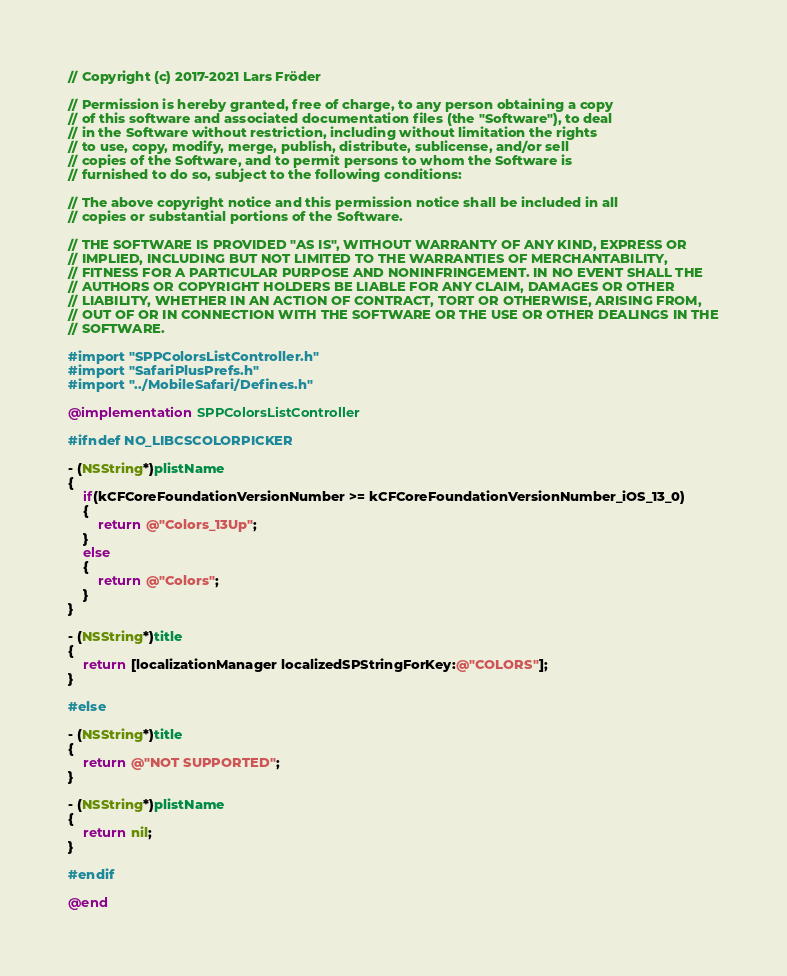Convert code to text. <code><loc_0><loc_0><loc_500><loc_500><_ObjectiveC_>// Copyright (c) 2017-2021 Lars Fröder

// Permission is hereby granted, free of charge, to any person obtaining a copy
// of this software and associated documentation files (the "Software"), to deal
// in the Software without restriction, including without limitation the rights
// to use, copy, modify, merge, publish, distribute, sublicense, and/or sell
// copies of the Software, and to permit persons to whom the Software is
// furnished to do so, subject to the following conditions:

// The above copyright notice and this permission notice shall be included in all
// copies or substantial portions of the Software.

// THE SOFTWARE IS PROVIDED "AS IS", WITHOUT WARRANTY OF ANY KIND, EXPRESS OR
// IMPLIED, INCLUDING BUT NOT LIMITED TO THE WARRANTIES OF MERCHANTABILITY,
// FITNESS FOR A PARTICULAR PURPOSE AND NONINFRINGEMENT. IN NO EVENT SHALL THE
// AUTHORS OR COPYRIGHT HOLDERS BE LIABLE FOR ANY CLAIM, DAMAGES OR OTHER
// LIABILITY, WHETHER IN AN ACTION OF CONTRACT, TORT OR OTHERWISE, ARISING FROM,
// OUT OF OR IN CONNECTION WITH THE SOFTWARE OR THE USE OR OTHER DEALINGS IN THE
// SOFTWARE.

#import "SPPColorsListController.h"
#import "SafariPlusPrefs.h"
#import "../MobileSafari/Defines.h"

@implementation SPPColorsListController

#ifndef NO_LIBCSCOLORPICKER

- (NSString*)plistName
{
	if(kCFCoreFoundationVersionNumber >= kCFCoreFoundationVersionNumber_iOS_13_0)
	{
		return @"Colors_13Up";
	}
	else
	{
		return @"Colors";
	}
}

- (NSString*)title
{
	return [localizationManager localizedSPStringForKey:@"COLORS"];
}

#else

- (NSString*)title
{
	return @"NOT SUPPORTED";
}

- (NSString*)plistName
{
	return nil;
}

#endif

@end
</code> 